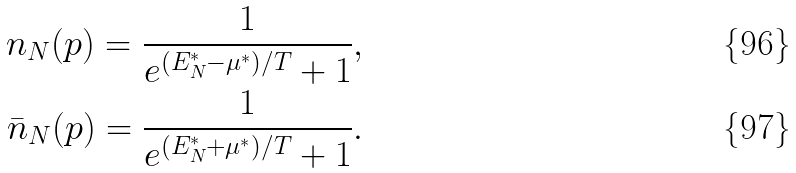<formula> <loc_0><loc_0><loc_500><loc_500>n _ { N } ( p ) = \frac { 1 } { e ^ { ( E _ { N } ^ { * } - \mu ^ { * } ) / T } + 1 } , \\ \bar { n } _ { N } ( p ) = \frac { 1 } { e ^ { ( E _ { N } ^ { * } + \mu ^ { * } ) / T } + 1 } .</formula> 